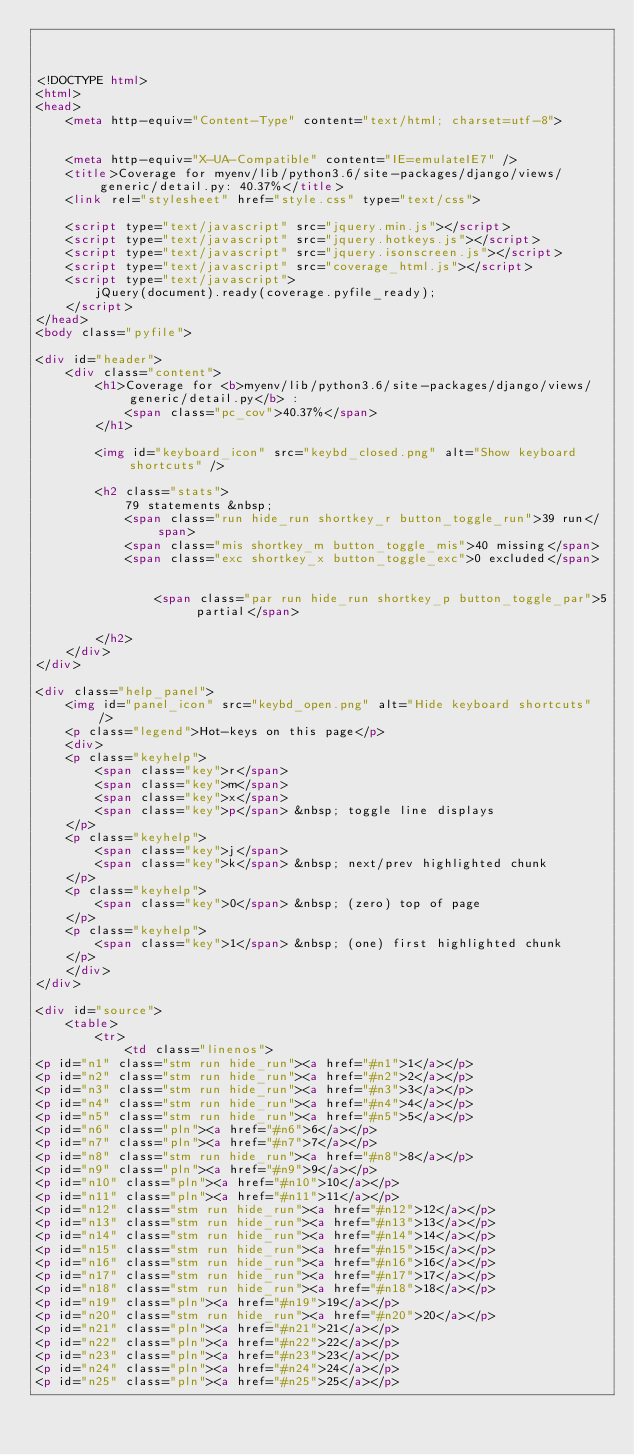Convert code to text. <code><loc_0><loc_0><loc_500><loc_500><_HTML_>


<!DOCTYPE html>
<html>
<head>
    <meta http-equiv="Content-Type" content="text/html; charset=utf-8">
    
    
    <meta http-equiv="X-UA-Compatible" content="IE=emulateIE7" />
    <title>Coverage for myenv/lib/python3.6/site-packages/django/views/generic/detail.py: 40.37%</title>
    <link rel="stylesheet" href="style.css" type="text/css">
    
    <script type="text/javascript" src="jquery.min.js"></script>
    <script type="text/javascript" src="jquery.hotkeys.js"></script>
    <script type="text/javascript" src="jquery.isonscreen.js"></script>
    <script type="text/javascript" src="coverage_html.js"></script>
    <script type="text/javascript">
        jQuery(document).ready(coverage.pyfile_ready);
    </script>
</head>
<body class="pyfile">

<div id="header">
    <div class="content">
        <h1>Coverage for <b>myenv/lib/python3.6/site-packages/django/views/generic/detail.py</b> :
            <span class="pc_cov">40.37%</span>
        </h1>

        <img id="keyboard_icon" src="keybd_closed.png" alt="Show keyboard shortcuts" />

        <h2 class="stats">
            79 statements &nbsp;
            <span class="run hide_run shortkey_r button_toggle_run">39 run</span>
            <span class="mis shortkey_m button_toggle_mis">40 missing</span>
            <span class="exc shortkey_x button_toggle_exc">0 excluded</span>

            
                <span class="par run hide_run shortkey_p button_toggle_par">5 partial</span>
            
        </h2>
    </div>
</div>

<div class="help_panel">
    <img id="panel_icon" src="keybd_open.png" alt="Hide keyboard shortcuts" />
    <p class="legend">Hot-keys on this page</p>
    <div>
    <p class="keyhelp">
        <span class="key">r</span>
        <span class="key">m</span>
        <span class="key">x</span>
        <span class="key">p</span> &nbsp; toggle line displays
    </p>
    <p class="keyhelp">
        <span class="key">j</span>
        <span class="key">k</span> &nbsp; next/prev highlighted chunk
    </p>
    <p class="keyhelp">
        <span class="key">0</span> &nbsp; (zero) top of page
    </p>
    <p class="keyhelp">
        <span class="key">1</span> &nbsp; (one) first highlighted chunk
    </p>
    </div>
</div>

<div id="source">
    <table>
        <tr>
            <td class="linenos">
<p id="n1" class="stm run hide_run"><a href="#n1">1</a></p>
<p id="n2" class="stm run hide_run"><a href="#n2">2</a></p>
<p id="n3" class="stm run hide_run"><a href="#n3">3</a></p>
<p id="n4" class="stm run hide_run"><a href="#n4">4</a></p>
<p id="n5" class="stm run hide_run"><a href="#n5">5</a></p>
<p id="n6" class="pln"><a href="#n6">6</a></p>
<p id="n7" class="pln"><a href="#n7">7</a></p>
<p id="n8" class="stm run hide_run"><a href="#n8">8</a></p>
<p id="n9" class="pln"><a href="#n9">9</a></p>
<p id="n10" class="pln"><a href="#n10">10</a></p>
<p id="n11" class="pln"><a href="#n11">11</a></p>
<p id="n12" class="stm run hide_run"><a href="#n12">12</a></p>
<p id="n13" class="stm run hide_run"><a href="#n13">13</a></p>
<p id="n14" class="stm run hide_run"><a href="#n14">14</a></p>
<p id="n15" class="stm run hide_run"><a href="#n15">15</a></p>
<p id="n16" class="stm run hide_run"><a href="#n16">16</a></p>
<p id="n17" class="stm run hide_run"><a href="#n17">17</a></p>
<p id="n18" class="stm run hide_run"><a href="#n18">18</a></p>
<p id="n19" class="pln"><a href="#n19">19</a></p>
<p id="n20" class="stm run hide_run"><a href="#n20">20</a></p>
<p id="n21" class="pln"><a href="#n21">21</a></p>
<p id="n22" class="pln"><a href="#n22">22</a></p>
<p id="n23" class="pln"><a href="#n23">23</a></p>
<p id="n24" class="pln"><a href="#n24">24</a></p>
<p id="n25" class="pln"><a href="#n25">25</a></p></code> 